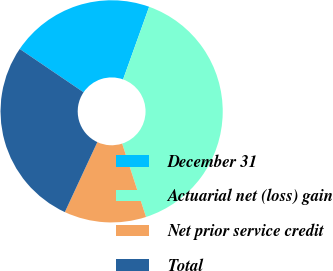Convert chart to OTSL. <chart><loc_0><loc_0><loc_500><loc_500><pie_chart><fcel>December 31<fcel>Actuarial net (loss) gain<fcel>Net prior service credit<fcel>Total<nl><fcel>20.99%<fcel>39.5%<fcel>11.93%<fcel>27.57%<nl></chart> 